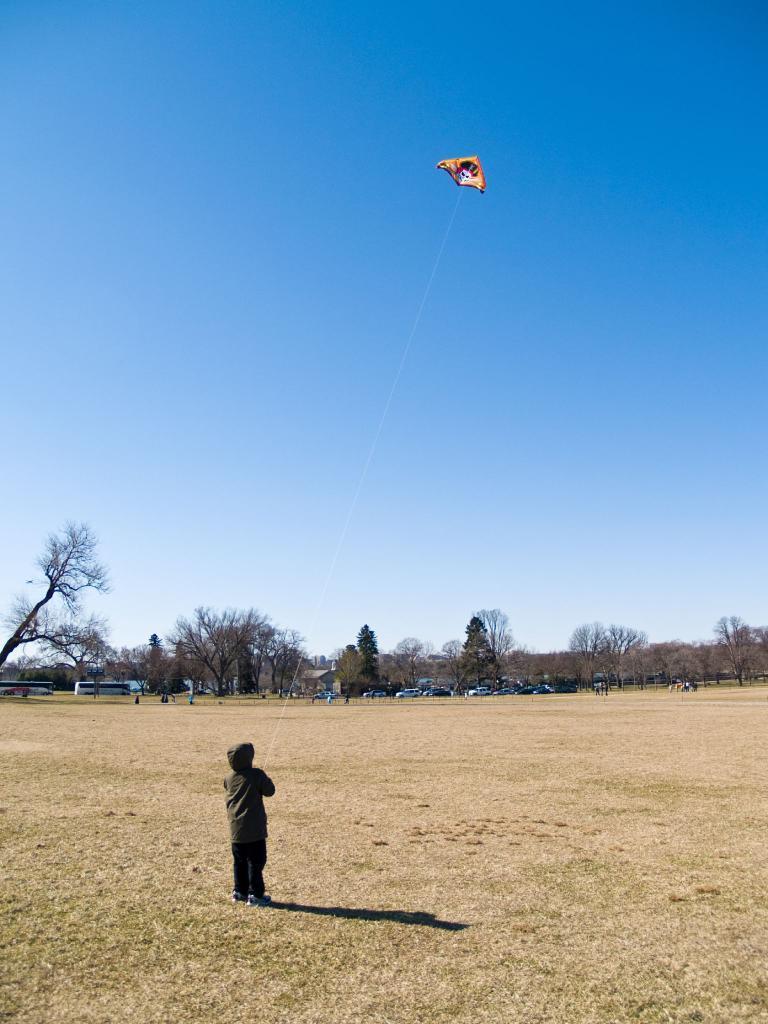Can you describe this image briefly? In this picture I can see a boy flying the kite at the bottom, in the background there are vehicles, trees. At the top there is the sky. 